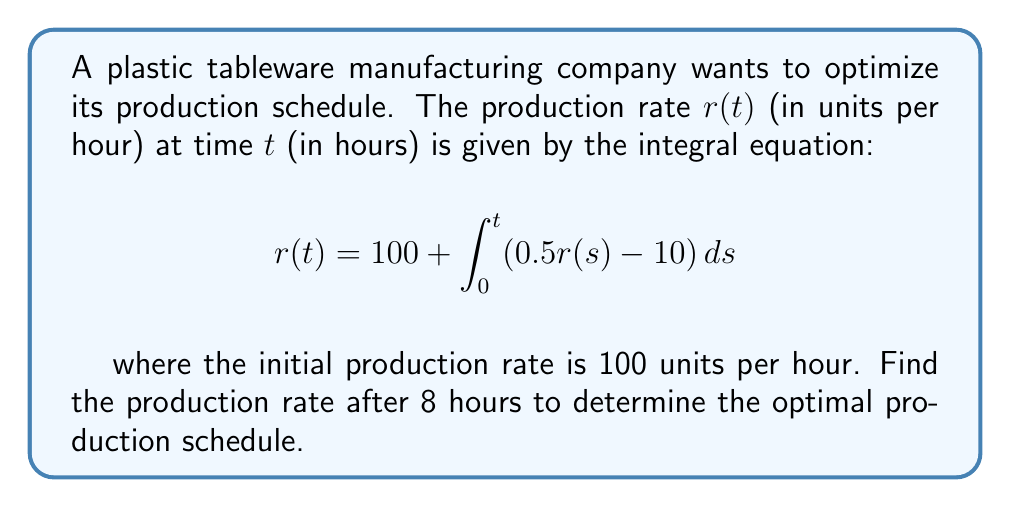Help me with this question. To solve this integral equation, we'll follow these steps:

1) First, we differentiate both sides of the equation with respect to $t$:

   $$\frac{d}{dt}r(t) = \frac{d}{dt}\left[100 + \int_0^t (0.5r(s) - 10) ds\right]$$

2) Using the Fundamental Theorem of Calculus, we get:

   $$\frac{dr}{dt} = 0.5r(t) - 10$$

3) This is a first-order linear differential equation. We can rewrite it as:

   $$\frac{dr}{dt} - 0.5r = -10$$

4) The general solution to this equation is:

   $$r(t) = Ce^{0.5t} + 20$$

   where $C$ is a constant to be determined.

5) We use the initial condition $r(0) = 100$ to find $C$:

   $$100 = Ce^{0(0.5)} + 20$$
   $$C = 80$$

6) Therefore, the particular solution is:

   $$r(t) = 80e^{0.5t} + 20$$

7) To find the production rate after 8 hours, we substitute $t = 8$:

   $$r(8) = 80e^{0.5(8)} + 20 = 80e^4 + 20 \approx 4366.73$$

Thus, the production rate after 8 hours is approximately 4366.73 units per hour.
Answer: 4366.73 units per hour 